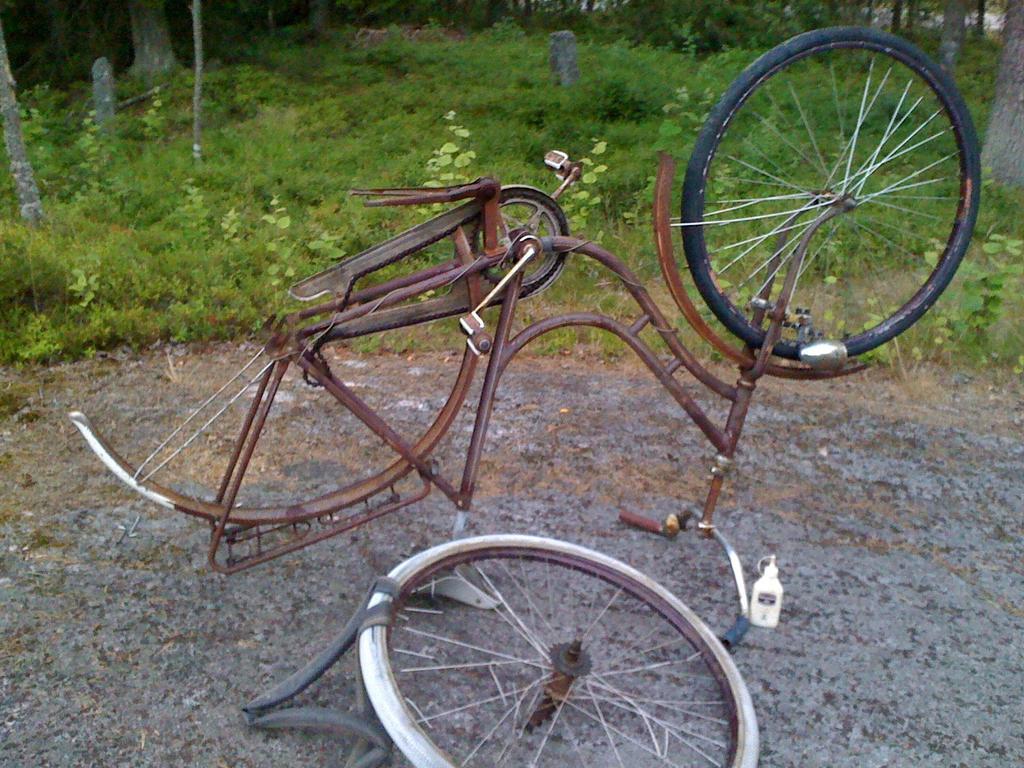Please provide a concise description of this image. In this image I can see a bicycle parts. They are in brown and black color. Back I can see green grass and trees. 